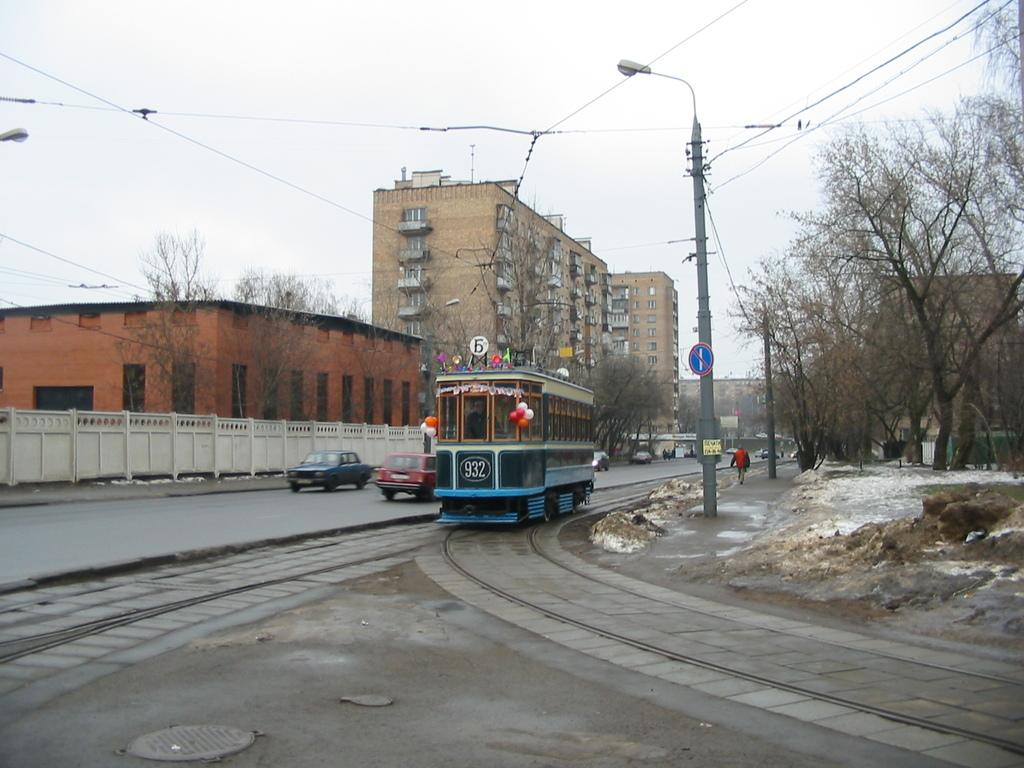Provide a one-sentence caption for the provided image. An in-service cable car is labeled with the number 932. 